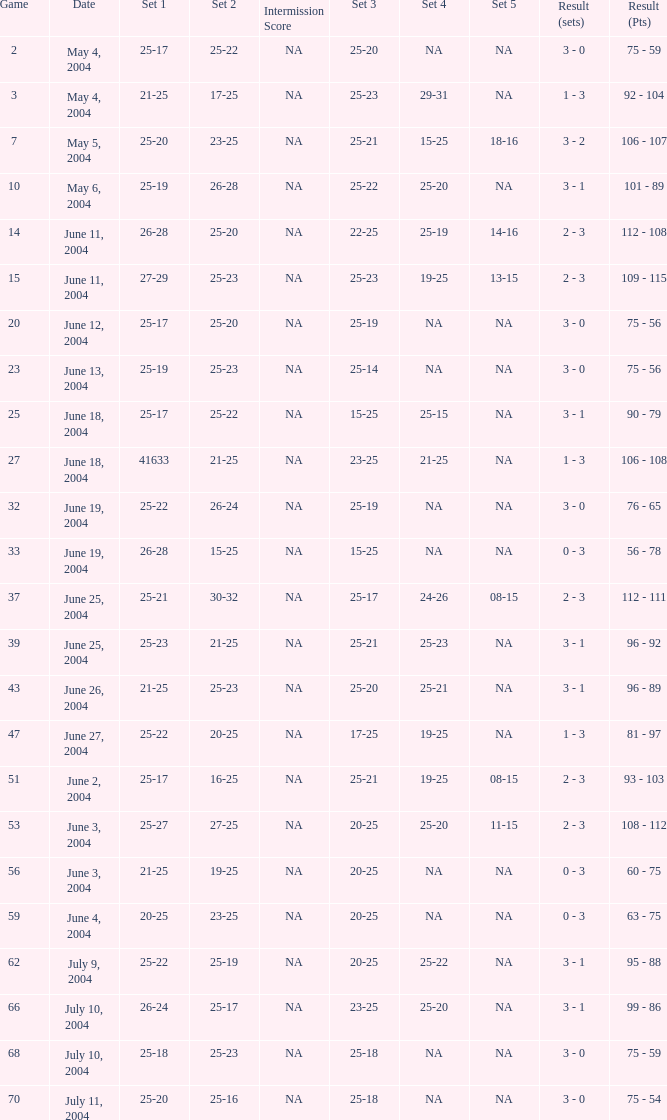What is the result of the game with a set 1 of 26-24? 99 - 86. Give me the full table as a dictionary. {'header': ['Game', 'Date', 'Set 1', 'Set 2', 'Intermission Score', 'Set 3', 'Set 4', 'Set 5', 'Result (sets)', 'Result (Pts)'], 'rows': [['2', 'May 4, 2004', '25-17', '25-22', 'NA', '25-20', 'NA', 'NA', '3 - 0', '75 - 59'], ['3', 'May 4, 2004', '21-25', '17-25', 'NA', '25-23', '29-31', 'NA', '1 - 3', '92 - 104'], ['7', 'May 5, 2004', '25-20', '23-25', 'NA', '25-21', '15-25', '18-16', '3 - 2', '106 - 107'], ['10', 'May 6, 2004', '25-19', '26-28', 'NA', '25-22', '25-20', 'NA', '3 - 1', '101 - 89'], ['14', 'June 11, 2004', '26-28', '25-20', 'NA', '22-25', '25-19', '14-16', '2 - 3', '112 - 108'], ['15', 'June 11, 2004', '27-29', '25-23', 'NA', '25-23', '19-25', '13-15', '2 - 3', '109 - 115'], ['20', 'June 12, 2004', '25-17', '25-20', 'NA', '25-19', 'NA', 'NA', '3 - 0', '75 - 56'], ['23', 'June 13, 2004', '25-19', '25-23', 'NA', '25-14', 'NA', 'NA', '3 - 0', '75 - 56'], ['25', 'June 18, 2004', '25-17', '25-22', 'NA', '15-25', '25-15', 'NA', '3 - 1', '90 - 79'], ['27', 'June 18, 2004', '41633', '21-25', 'NA', '23-25', '21-25', 'NA', '1 - 3', '106 - 108'], ['32', 'June 19, 2004', '25-22', '26-24', 'NA', '25-19', 'NA', 'NA', '3 - 0', '76 - 65'], ['33', 'June 19, 2004', '26-28', '15-25', 'NA', '15-25', 'NA', 'NA', '0 - 3', '56 - 78'], ['37', 'June 25, 2004', '25-21', '30-32', 'NA', '25-17', '24-26', '08-15', '2 - 3', '112 - 111'], ['39', 'June 25, 2004', '25-23', '21-25', 'NA', '25-21', '25-23', 'NA', '3 - 1', '96 - 92'], ['43', 'June 26, 2004', '21-25', '25-23', 'NA', '25-20', '25-21', 'NA', '3 - 1', '96 - 89'], ['47', 'June 27, 2004', '25-22', '20-25', 'NA', '17-25', '19-25', 'NA', '1 - 3', '81 - 97'], ['51', 'June 2, 2004', '25-17', '16-25', 'NA', '25-21', '19-25', '08-15', '2 - 3', '93 - 103'], ['53', 'June 3, 2004', '25-27', '27-25', 'NA', '20-25', '25-20', '11-15', '2 - 3', '108 - 112'], ['56', 'June 3, 2004', '21-25', '19-25', 'NA', '20-25', 'NA', 'NA', '0 - 3', '60 - 75'], ['59', 'June 4, 2004', '20-25', '23-25', 'NA', '20-25', 'NA', 'NA', '0 - 3', '63 - 75'], ['62', 'July 9, 2004', '25-22', '25-19', 'NA', '20-25', '25-22', 'NA', '3 - 1', '95 - 88'], ['66', 'July 10, 2004', '26-24', '25-17', 'NA', '23-25', '25-20', 'NA', '3 - 1', '99 - 86'], ['68', 'July 10, 2004', '25-18', '25-23', 'NA', '25-18', 'NA', 'NA', '3 - 0', '75 - 59'], ['70', 'July 11, 2004', '25-20', '25-16', 'NA', '25-18', 'NA', 'NA', '3 - 0', '75 - 54']]} 